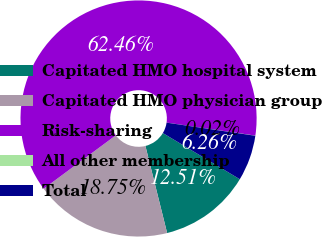Convert chart. <chart><loc_0><loc_0><loc_500><loc_500><pie_chart><fcel>Capitated HMO hospital system<fcel>Capitated HMO physician group<fcel>Risk-sharing<fcel>All other membership<fcel>Total<nl><fcel>12.51%<fcel>18.75%<fcel>62.47%<fcel>0.02%<fcel>6.26%<nl></chart> 